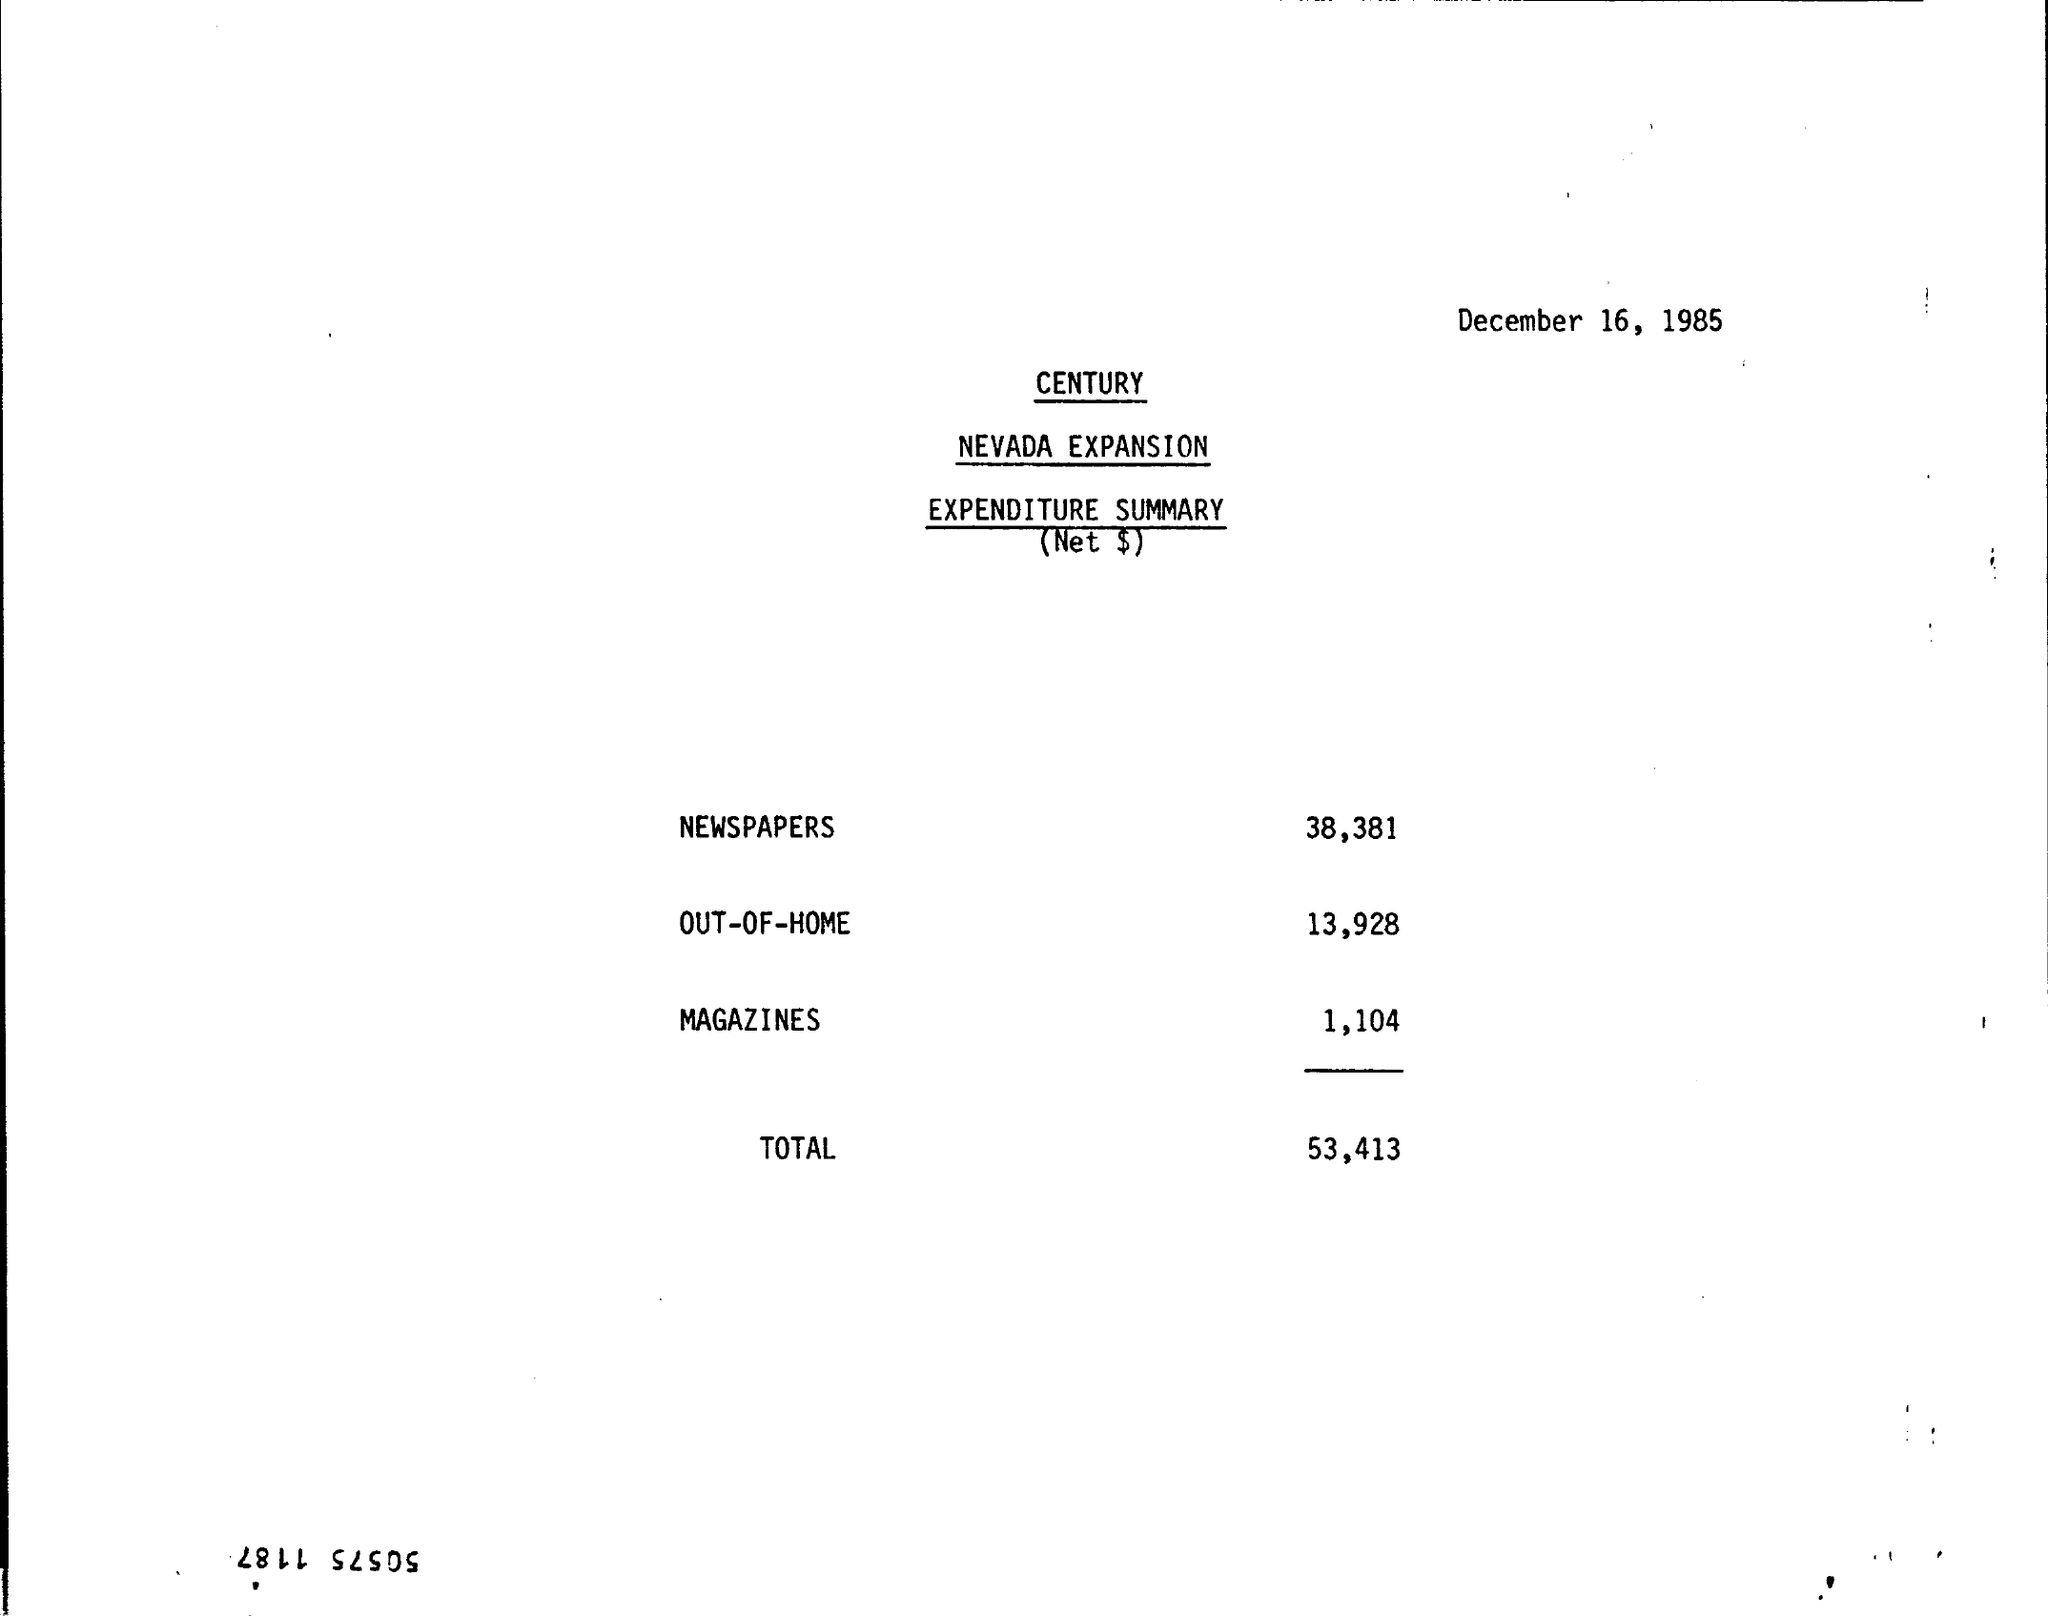Can you tell how much was spent on newspapers according to the expenditure summary? The expenditure summary indicates that $38,381 was spent on newspapers. 